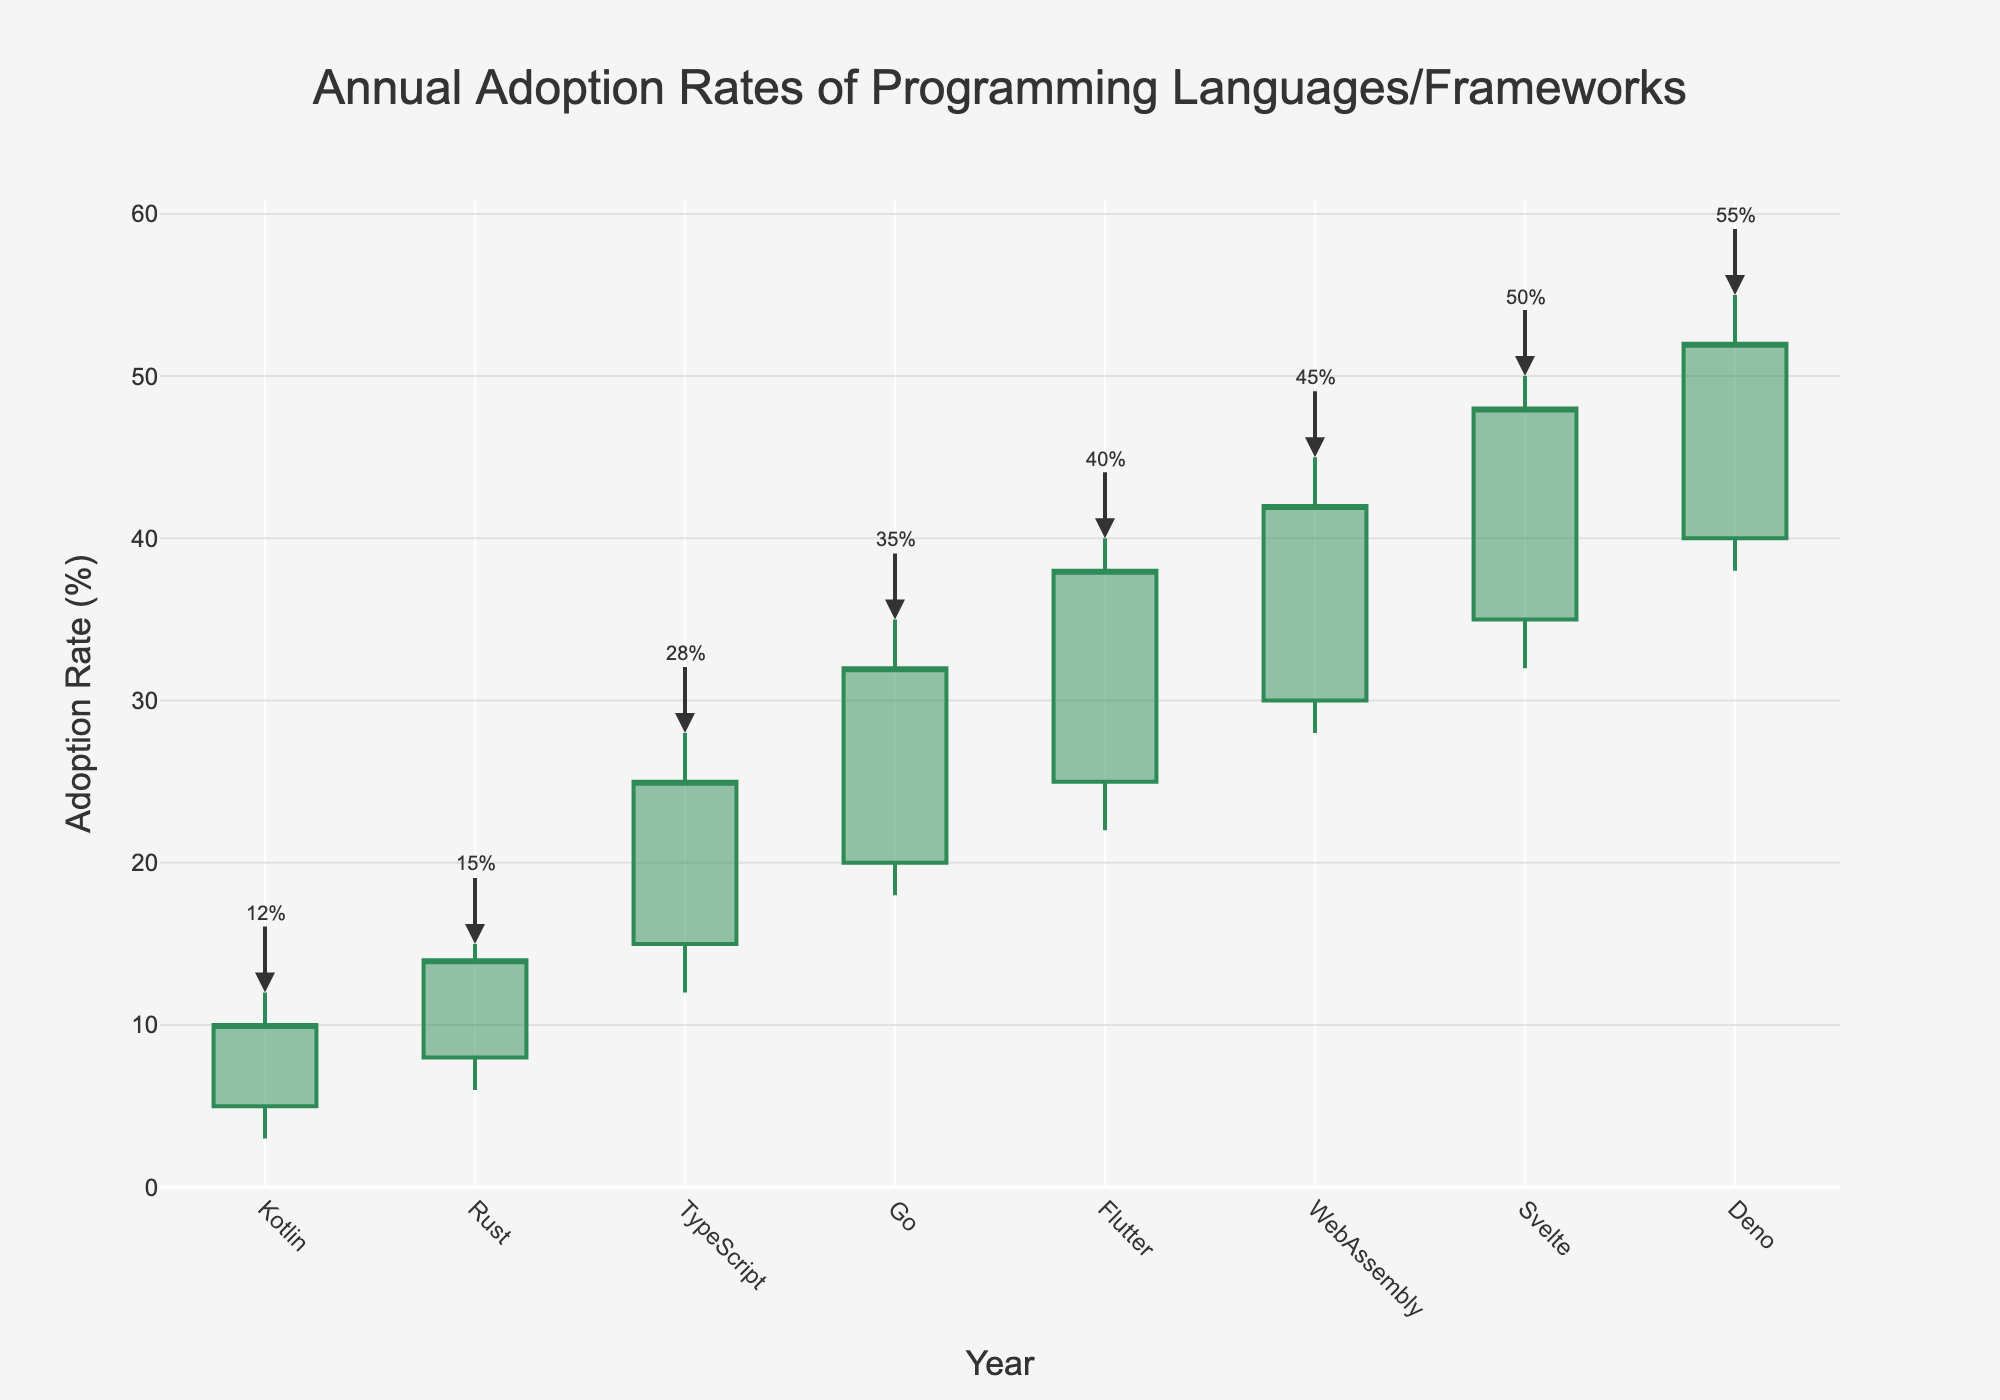What is the title of the figure? The title of the figure is typically displayed at the top and summarizes the main topic of the chart. In this case, it reads, "Annual Adoption Rates of Programming Languages/Frameworks".
Answer: Annual Adoption Rates of Programming Languages/Frameworks How many different programming languages or frameworks are included in the chart? To answer this, count the unique data points plotted on the x-axis. There are 8 different languages or frameworks included from 2019 to 2026.
Answer: 8 Which year shows the highest adoption rate for the programming language or framework? The highest adoption rate can be identified by looking at the highest peak on the chart. The year 2026 has the highest point with Deno peaking at 55%.
Answer: 2026 What was the lowest adoption rate recorded for the TypeScript in 2021? To find this, locate the entry for TypeScript in 2021 and identify the 'low' value in the candlestick, which is labeled directly below the box plot representing that year's data. It was 12%.
Answer: 12% Compare the opening adoption rates of Kotlin in 2019 and Svelte in 2025. Which one had a higher opening rate, and what is the difference? The opening rates for Kotlin in 2019 and Svelte in 2025 are 5% and 35%, respectively. Svelte's opening rate is higher. The difference is 35% - 5% = 30%.
Answer: Svelte had a higher opening rate by 30% In which year did the Flutter framework see its highest adoption rate, and what was the percentage? Looking at the Flutter entry for 2023, the highest point (high value) on the candlestick shows the adoption rate, which is recorded at 40%.
Answer: 2023, 40% Calculate the average closing adoption rate across all years. Sum the closing rates and divide by the number of years: (10 + 14 + 25 + 32 + 38 + 42 + 48 + 52) / 8 = 32.625.
Answer: 32.625 What trend can be observed about the adoption rates from 2019 to 2026? The general trend can be observed by examining the progression of the candlesticks. Starting from relatively low adoption rates in the early years, there is a consistent increase annually.
Answer: Increasing trend Which language or framework experienced the largest single-year increase in adoption rate? Compare the differences between the closing values of subsequent years. Rust from 2020 to TypeScript in 2021 saw the largest increase, from a close of 14% to 25%, a 11% increase.
Answer: Rust to TypeScript, 11% Between 2022 and 2023, which year's language or framework had a greater adoption rate and by how much? Looking at the 'close' values for 2022 (Go) and 2023 (Flutter), compare the figures: 32% (Go) and 38% (Flutter). Flutter in 2023 had a greater adoption rate by 38% - 32% = 6%.
Answer: 2023 by 6% 